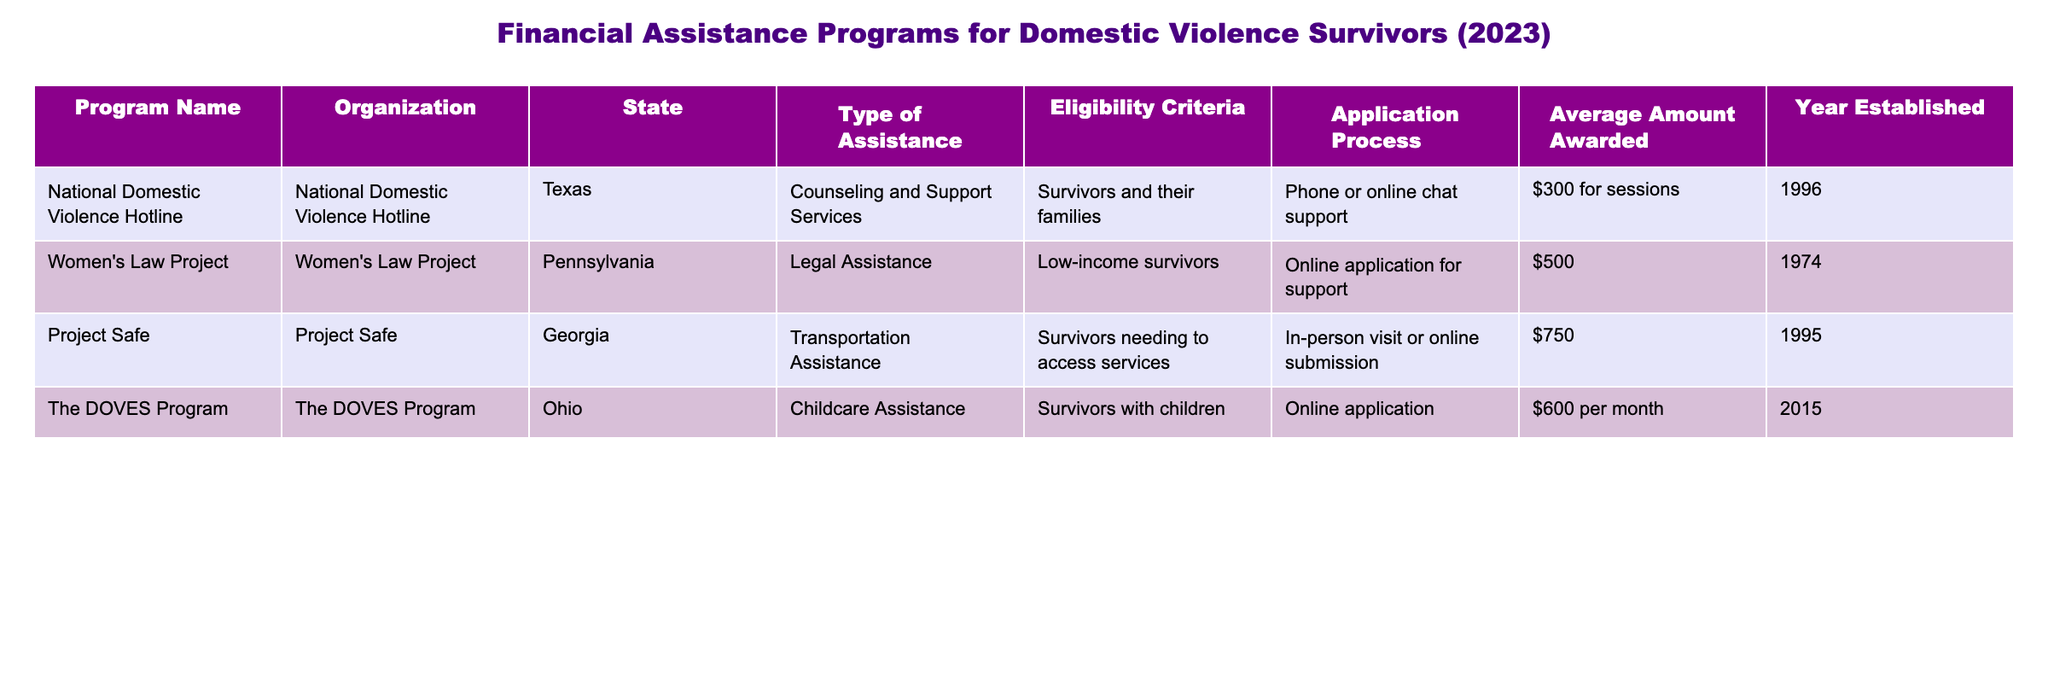What type of assistance is provided by the Women's Law Project? From the table, I can see that under the "Type of Assistance" column, the Women's Law Project offers "Legal Assistance."
Answer: Legal Assistance Which organization offers childcare assistance in Ohio? Referring to the "Organization" column, The DOVES Program is listed as providing "Childcare Assistance" in Ohio.
Answer: The DOVES Program What is the average amount awarded for transportation assistance? The amount awarded for transportation assistance provided by Project Safe is $750, which can be directly read from the table under the relevant column for that program.
Answer: $750 Are survivors with children eligible for assistance from The DOVES Program? The eligibility criteria for The DOVES Program mentions "Survivors with children," indicating that they are indeed eligible.
Answer: Yes What is the total average amount awarded across all programs listed? I will add the average amounts: $300 (National Domestic Violence Hotline) + $500 (Women's Law Project) + $750 (Project Safe) + $600 (The DOVES Program) = $2150, then divide by 4 (the total number of programs), which results in an average of $537.50.
Answer: $537.50 In how many states is financial assistance provided according to this table? By reviewing the states listed (Texas, Pennsylvania, Georgia, Ohio), I can count four distinct states.
Answer: 4 Does the National Domestic Violence Hotline provide in-person counseling? The application process described for the National Domestic Violence Hotline is "Phone or online chat support," indicating that it does not offer in-person counseling.
Answer: No Which program has the highest amount awarded? By comparing the amounts awarded: $300, $500, $750, and $600, it is clear that the highest is provided by Project Safe with $750.
Answer: Project Safe What is the eligibility criteria for the Women's Law Project? The table states "Low-income survivors" as the eligibility criteria for the Women's Law Project.
Answer: Low-income survivors 